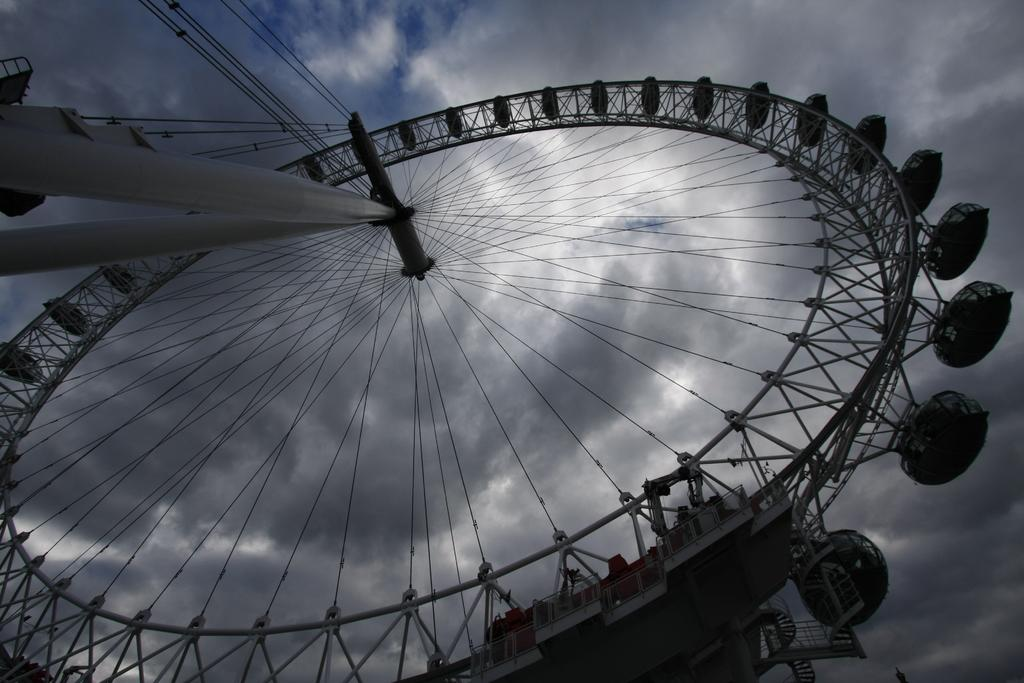What type of structure is present in the image? There is a Columbus wheel in the picture. How would you describe the weather based on the image? The sky is cloudy in the picture, suggesting a potentially overcast or cloudy day. How many cards are being held by the person wearing a vest in the image? There is no person wearing a vest or holding cards present in the image; it only features a Columbus wheel and a cloudy sky. 